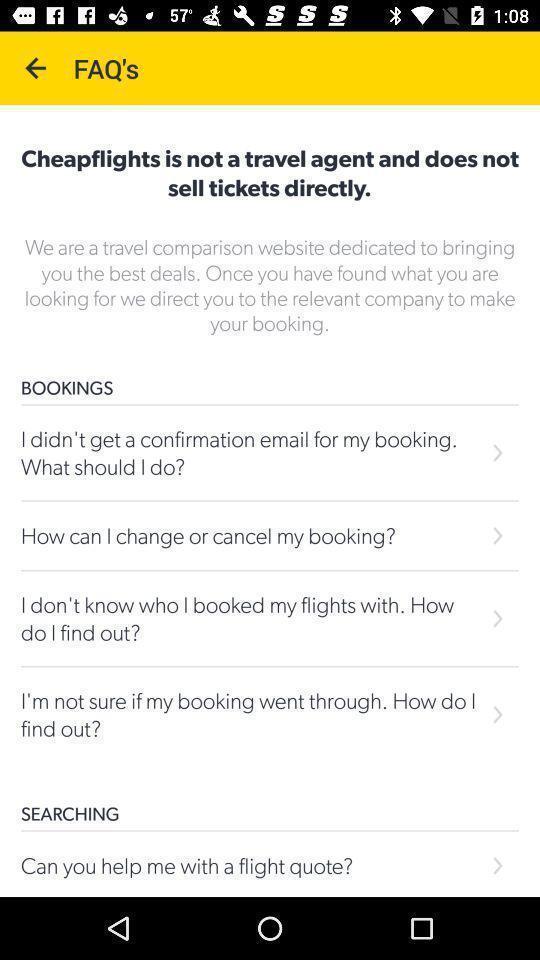Describe the content in this image. Screen shows frequently asked questions page in the travel application. 